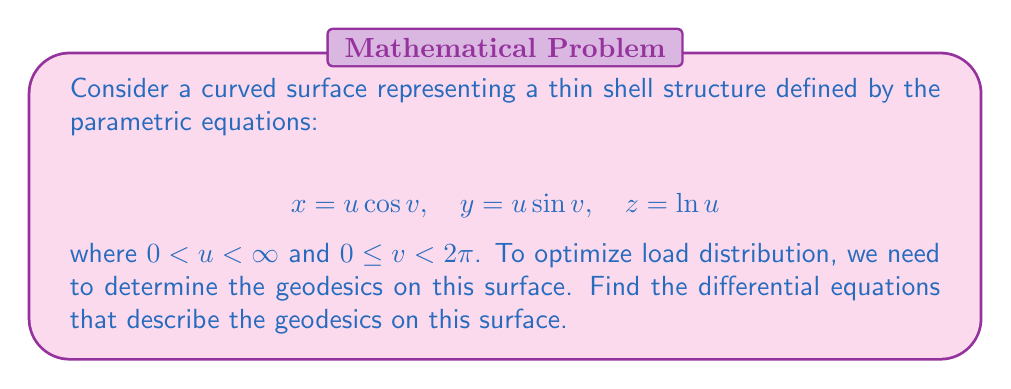Could you help me with this problem? To find the differential equations of geodesics on the given surface, we'll follow these steps:

1. Calculate the first fundamental form coefficients:
   $$E = \left(\frac{\partial x}{\partial u}\right)^2 + \left(\frac{\partial y}{\partial u}\right)^2 + \left(\frac{\partial z}{\partial u}\right)^2$$
   $$F = \frac{\partial x}{\partial u}\frac{\partial x}{\partial v} + \frac{\partial y}{\partial u}\frac{\partial y}{\partial v} + \frac{\partial z}{\partial u}\frac{\partial z}{\partial v}$$
   $$G = \left(\frac{\partial x}{\partial v}\right)^2 + \left(\frac{\partial y}{\partial v}\right)^2 + \left(\frac{\partial z}{\partial v}\right)^2$$

2. Compute the partial derivatives:
   $$\frac{\partial x}{\partial u} = \cos v, \quad \frac{\partial x}{\partial v} = -u \sin v$$
   $$\frac{\partial y}{\partial u} = \sin v, \quad \frac{\partial y}{\partial v} = u \cos v$$
   $$\frac{\partial z}{\partial u} = \frac{1}{u}, \quad \frac{\partial z}{\partial v} = 0$$

3. Calculate E, F, and G:
   $$E = \cos^2 v + \sin^2 v + \frac{1}{u^2} = 1 + \frac{1}{u^2}$$
   $$F = -u \sin v \cos v + u \sin v \cos v + 0 = 0$$
   $$G = u^2 \sin^2 v + u^2 \cos^2 v + 0 = u^2$$

4. Use the Euler-Lagrange equations for geodesics:
   $$\frac{d}{dt}\left(E\frac{du}{dt} + F\frac{dv}{dt}\right) - \frac{1}{2}\frac{\partial E}{\partial u}\left(\frac{du}{dt}\right)^2 - \frac{\partial F}{\partial u}\frac{du}{dt}\frac{dv}{dt} - \frac{1}{2}\frac{\partial G}{\partial u}\left(\frac{dv}{dt}\right)^2 = 0$$
   $$\frac{d}{dt}\left(F\frac{du}{dt} + G\frac{dv}{dt}\right) - \frac{1}{2}\frac{\partial E}{\partial v}\left(\frac{du}{dt}\right)^2 - \frac{\partial F}{\partial v}\frac{du}{dt}\frac{dv}{dt} - \frac{1}{2}\frac{\partial G}{\partial v}\left(\frac{dv}{dt}\right)^2 = 0$$

5. Substitute the values and simplify:
   $$\frac{d}{dt}\left(\left(1+\frac{1}{u^2}\right)\frac{du}{dt}\right) + \frac{1}{u^3}\left(\frac{du}{dt}\right)^2 - u\left(\frac{dv}{dt}\right)^2 = 0$$
   $$\frac{d}{dt}\left(u^2\frac{dv}{dt}\right) = 0$$

These are the differential equations that describe the geodesics on the given surface.
Answer: $$\frac{d}{dt}\left(\left(1+\frac{1}{u^2}\right)\frac{du}{dt}\right) + \frac{1}{u^3}\left(\frac{du}{dt}\right)^2 - u\left(\frac{dv}{dt}\right)^2 = 0$$
$$\frac{d}{dt}\left(u^2\frac{dv}{dt}\right) = 0$$ 